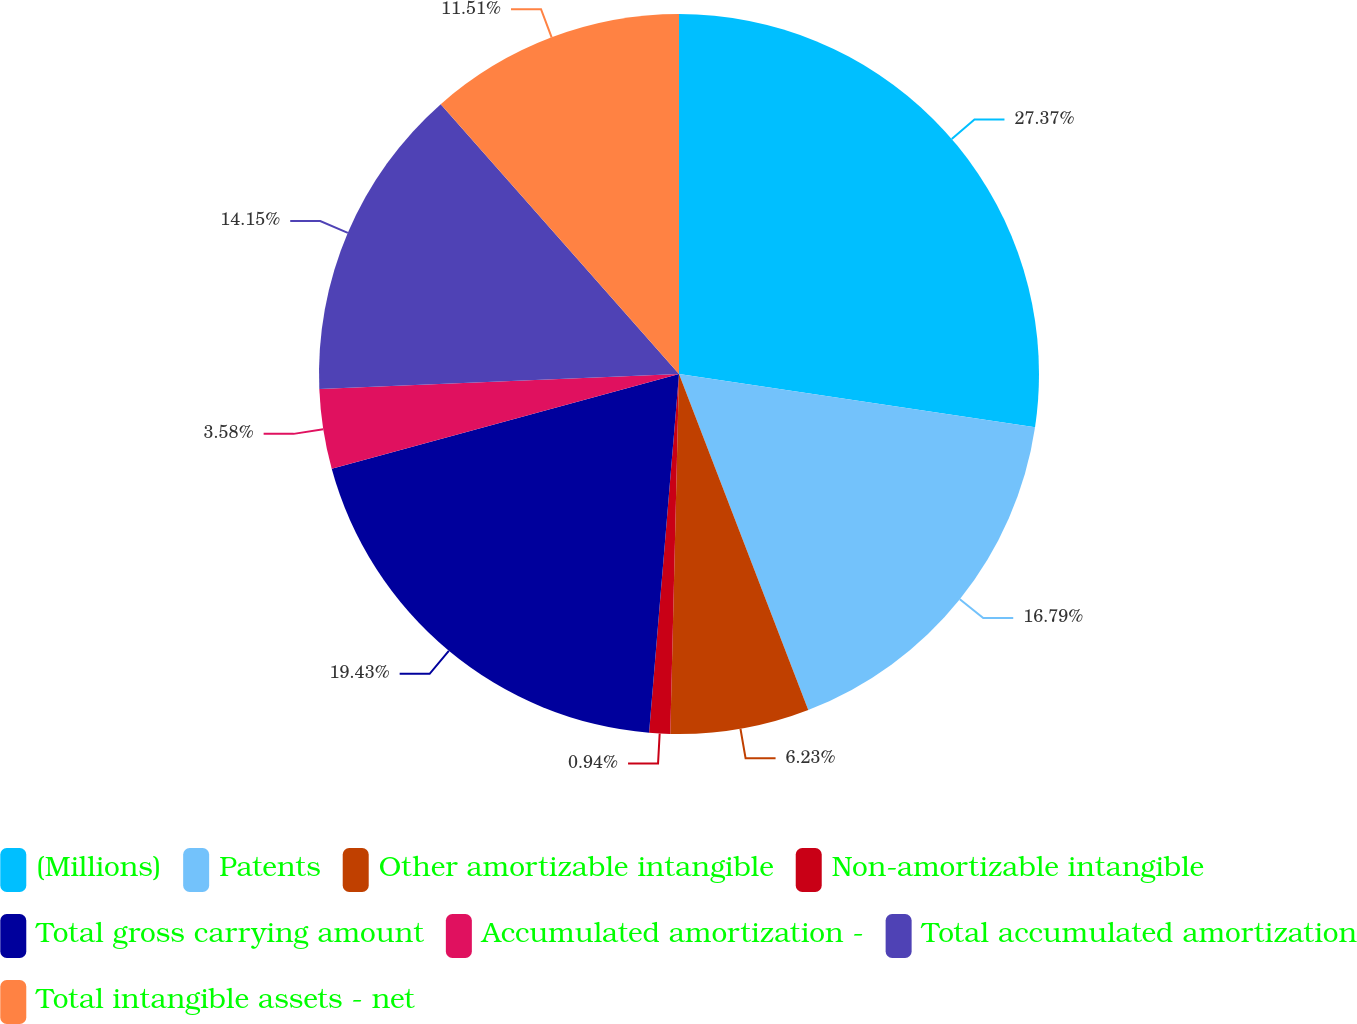Convert chart. <chart><loc_0><loc_0><loc_500><loc_500><pie_chart><fcel>(Millions)<fcel>Patents<fcel>Other amortizable intangible<fcel>Non-amortizable intangible<fcel>Total gross carrying amount<fcel>Accumulated amortization -<fcel>Total accumulated amortization<fcel>Total intangible assets - net<nl><fcel>27.36%<fcel>16.79%<fcel>6.23%<fcel>0.94%<fcel>19.43%<fcel>3.58%<fcel>14.15%<fcel>11.51%<nl></chart> 